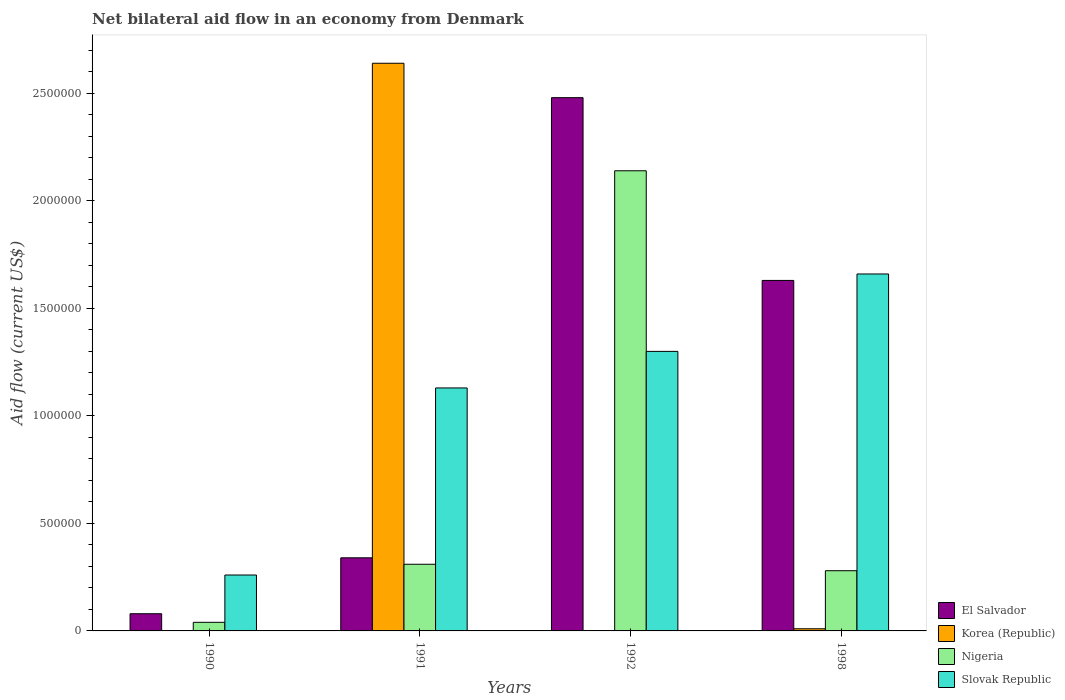In how many cases, is the number of bars for a given year not equal to the number of legend labels?
Your answer should be compact. 2. Across all years, what is the maximum net bilateral aid flow in Nigeria?
Offer a very short reply. 2.14e+06. Across all years, what is the minimum net bilateral aid flow in Korea (Republic)?
Provide a short and direct response. 0. In which year was the net bilateral aid flow in Nigeria maximum?
Make the answer very short. 1992. What is the total net bilateral aid flow in El Salvador in the graph?
Offer a very short reply. 4.53e+06. What is the difference between the net bilateral aid flow in Nigeria in 1992 and the net bilateral aid flow in El Salvador in 1998?
Your answer should be compact. 5.10e+05. What is the average net bilateral aid flow in Nigeria per year?
Ensure brevity in your answer.  6.92e+05. In the year 1998, what is the difference between the net bilateral aid flow in Slovak Republic and net bilateral aid flow in Nigeria?
Make the answer very short. 1.38e+06. In how many years, is the net bilateral aid flow in Slovak Republic greater than 2600000 US$?
Keep it short and to the point. 0. What is the ratio of the net bilateral aid flow in El Salvador in 1991 to that in 1992?
Your response must be concise. 0.14. Is the net bilateral aid flow in Slovak Republic in 1991 less than that in 1998?
Give a very brief answer. Yes. Is the difference between the net bilateral aid flow in Slovak Republic in 1991 and 1992 greater than the difference between the net bilateral aid flow in Nigeria in 1991 and 1992?
Make the answer very short. Yes. What is the difference between the highest and the second highest net bilateral aid flow in Nigeria?
Your answer should be compact. 1.83e+06. What is the difference between the highest and the lowest net bilateral aid flow in Slovak Republic?
Your answer should be very brief. 1.40e+06. In how many years, is the net bilateral aid flow in Korea (Republic) greater than the average net bilateral aid flow in Korea (Republic) taken over all years?
Your response must be concise. 1. How many bars are there?
Provide a succinct answer. 14. How many years are there in the graph?
Offer a terse response. 4. What is the difference between two consecutive major ticks on the Y-axis?
Offer a terse response. 5.00e+05. Are the values on the major ticks of Y-axis written in scientific E-notation?
Your answer should be very brief. No. Does the graph contain grids?
Ensure brevity in your answer.  No. How many legend labels are there?
Your response must be concise. 4. What is the title of the graph?
Provide a succinct answer. Net bilateral aid flow in an economy from Denmark. What is the label or title of the X-axis?
Provide a short and direct response. Years. What is the label or title of the Y-axis?
Make the answer very short. Aid flow (current US$). What is the Aid flow (current US$) of El Salvador in 1990?
Offer a terse response. 8.00e+04. What is the Aid flow (current US$) of Korea (Republic) in 1990?
Keep it short and to the point. 0. What is the Aid flow (current US$) of Slovak Republic in 1990?
Provide a succinct answer. 2.60e+05. What is the Aid flow (current US$) in Korea (Republic) in 1991?
Your answer should be compact. 2.64e+06. What is the Aid flow (current US$) in Slovak Republic in 1991?
Your answer should be very brief. 1.13e+06. What is the Aid flow (current US$) in El Salvador in 1992?
Offer a very short reply. 2.48e+06. What is the Aid flow (current US$) of Korea (Republic) in 1992?
Provide a succinct answer. 0. What is the Aid flow (current US$) of Nigeria in 1992?
Your answer should be very brief. 2.14e+06. What is the Aid flow (current US$) in Slovak Republic in 1992?
Your answer should be compact. 1.30e+06. What is the Aid flow (current US$) of El Salvador in 1998?
Your response must be concise. 1.63e+06. What is the Aid flow (current US$) in Korea (Republic) in 1998?
Provide a short and direct response. 10000. What is the Aid flow (current US$) of Nigeria in 1998?
Offer a terse response. 2.80e+05. What is the Aid flow (current US$) of Slovak Republic in 1998?
Provide a succinct answer. 1.66e+06. Across all years, what is the maximum Aid flow (current US$) of El Salvador?
Provide a short and direct response. 2.48e+06. Across all years, what is the maximum Aid flow (current US$) of Korea (Republic)?
Keep it short and to the point. 2.64e+06. Across all years, what is the maximum Aid flow (current US$) in Nigeria?
Make the answer very short. 2.14e+06. Across all years, what is the maximum Aid flow (current US$) of Slovak Republic?
Provide a short and direct response. 1.66e+06. Across all years, what is the minimum Aid flow (current US$) of Nigeria?
Keep it short and to the point. 4.00e+04. Across all years, what is the minimum Aid flow (current US$) in Slovak Republic?
Offer a terse response. 2.60e+05. What is the total Aid flow (current US$) in El Salvador in the graph?
Make the answer very short. 4.53e+06. What is the total Aid flow (current US$) of Korea (Republic) in the graph?
Make the answer very short. 2.65e+06. What is the total Aid flow (current US$) in Nigeria in the graph?
Offer a very short reply. 2.77e+06. What is the total Aid flow (current US$) in Slovak Republic in the graph?
Ensure brevity in your answer.  4.35e+06. What is the difference between the Aid flow (current US$) in Nigeria in 1990 and that in 1991?
Offer a terse response. -2.70e+05. What is the difference between the Aid flow (current US$) in Slovak Republic in 1990 and that in 1991?
Your response must be concise. -8.70e+05. What is the difference between the Aid flow (current US$) in El Salvador in 1990 and that in 1992?
Make the answer very short. -2.40e+06. What is the difference between the Aid flow (current US$) of Nigeria in 1990 and that in 1992?
Offer a terse response. -2.10e+06. What is the difference between the Aid flow (current US$) in Slovak Republic in 1990 and that in 1992?
Ensure brevity in your answer.  -1.04e+06. What is the difference between the Aid flow (current US$) in El Salvador in 1990 and that in 1998?
Provide a succinct answer. -1.55e+06. What is the difference between the Aid flow (current US$) of Slovak Republic in 1990 and that in 1998?
Ensure brevity in your answer.  -1.40e+06. What is the difference between the Aid flow (current US$) in El Salvador in 1991 and that in 1992?
Give a very brief answer. -2.14e+06. What is the difference between the Aid flow (current US$) in Nigeria in 1991 and that in 1992?
Offer a very short reply. -1.83e+06. What is the difference between the Aid flow (current US$) in El Salvador in 1991 and that in 1998?
Ensure brevity in your answer.  -1.29e+06. What is the difference between the Aid flow (current US$) of Korea (Republic) in 1991 and that in 1998?
Give a very brief answer. 2.63e+06. What is the difference between the Aid flow (current US$) in Slovak Republic in 1991 and that in 1998?
Your answer should be compact. -5.30e+05. What is the difference between the Aid flow (current US$) in El Salvador in 1992 and that in 1998?
Provide a succinct answer. 8.50e+05. What is the difference between the Aid flow (current US$) in Nigeria in 1992 and that in 1998?
Offer a terse response. 1.86e+06. What is the difference between the Aid flow (current US$) in Slovak Republic in 1992 and that in 1998?
Your response must be concise. -3.60e+05. What is the difference between the Aid flow (current US$) of El Salvador in 1990 and the Aid flow (current US$) of Korea (Republic) in 1991?
Offer a very short reply. -2.56e+06. What is the difference between the Aid flow (current US$) of El Salvador in 1990 and the Aid flow (current US$) of Slovak Republic in 1991?
Give a very brief answer. -1.05e+06. What is the difference between the Aid flow (current US$) in Nigeria in 1990 and the Aid flow (current US$) in Slovak Republic in 1991?
Your answer should be very brief. -1.09e+06. What is the difference between the Aid flow (current US$) of El Salvador in 1990 and the Aid flow (current US$) of Nigeria in 1992?
Ensure brevity in your answer.  -2.06e+06. What is the difference between the Aid flow (current US$) of El Salvador in 1990 and the Aid flow (current US$) of Slovak Republic in 1992?
Your answer should be compact. -1.22e+06. What is the difference between the Aid flow (current US$) in Nigeria in 1990 and the Aid flow (current US$) in Slovak Republic in 1992?
Provide a succinct answer. -1.26e+06. What is the difference between the Aid flow (current US$) in El Salvador in 1990 and the Aid flow (current US$) in Korea (Republic) in 1998?
Keep it short and to the point. 7.00e+04. What is the difference between the Aid flow (current US$) in El Salvador in 1990 and the Aid flow (current US$) in Nigeria in 1998?
Provide a short and direct response. -2.00e+05. What is the difference between the Aid flow (current US$) of El Salvador in 1990 and the Aid flow (current US$) of Slovak Republic in 1998?
Offer a terse response. -1.58e+06. What is the difference between the Aid flow (current US$) of Nigeria in 1990 and the Aid flow (current US$) of Slovak Republic in 1998?
Offer a very short reply. -1.62e+06. What is the difference between the Aid flow (current US$) of El Salvador in 1991 and the Aid flow (current US$) of Nigeria in 1992?
Keep it short and to the point. -1.80e+06. What is the difference between the Aid flow (current US$) of El Salvador in 1991 and the Aid flow (current US$) of Slovak Republic in 1992?
Your answer should be compact. -9.60e+05. What is the difference between the Aid flow (current US$) in Korea (Republic) in 1991 and the Aid flow (current US$) in Slovak Republic in 1992?
Provide a succinct answer. 1.34e+06. What is the difference between the Aid flow (current US$) of Nigeria in 1991 and the Aid flow (current US$) of Slovak Republic in 1992?
Your answer should be very brief. -9.90e+05. What is the difference between the Aid flow (current US$) of El Salvador in 1991 and the Aid flow (current US$) of Korea (Republic) in 1998?
Make the answer very short. 3.30e+05. What is the difference between the Aid flow (current US$) of El Salvador in 1991 and the Aid flow (current US$) of Slovak Republic in 1998?
Provide a short and direct response. -1.32e+06. What is the difference between the Aid flow (current US$) of Korea (Republic) in 1991 and the Aid flow (current US$) of Nigeria in 1998?
Keep it short and to the point. 2.36e+06. What is the difference between the Aid flow (current US$) in Korea (Republic) in 1991 and the Aid flow (current US$) in Slovak Republic in 1998?
Ensure brevity in your answer.  9.80e+05. What is the difference between the Aid flow (current US$) in Nigeria in 1991 and the Aid flow (current US$) in Slovak Republic in 1998?
Your answer should be compact. -1.35e+06. What is the difference between the Aid flow (current US$) of El Salvador in 1992 and the Aid flow (current US$) of Korea (Republic) in 1998?
Offer a terse response. 2.47e+06. What is the difference between the Aid flow (current US$) of El Salvador in 1992 and the Aid flow (current US$) of Nigeria in 1998?
Provide a short and direct response. 2.20e+06. What is the difference between the Aid flow (current US$) of El Salvador in 1992 and the Aid flow (current US$) of Slovak Republic in 1998?
Provide a short and direct response. 8.20e+05. What is the difference between the Aid flow (current US$) of Nigeria in 1992 and the Aid flow (current US$) of Slovak Republic in 1998?
Provide a short and direct response. 4.80e+05. What is the average Aid flow (current US$) in El Salvador per year?
Ensure brevity in your answer.  1.13e+06. What is the average Aid flow (current US$) in Korea (Republic) per year?
Make the answer very short. 6.62e+05. What is the average Aid flow (current US$) of Nigeria per year?
Provide a succinct answer. 6.92e+05. What is the average Aid flow (current US$) in Slovak Republic per year?
Your response must be concise. 1.09e+06. In the year 1990, what is the difference between the Aid flow (current US$) in El Salvador and Aid flow (current US$) in Nigeria?
Offer a very short reply. 4.00e+04. In the year 1990, what is the difference between the Aid flow (current US$) of El Salvador and Aid flow (current US$) of Slovak Republic?
Make the answer very short. -1.80e+05. In the year 1991, what is the difference between the Aid flow (current US$) of El Salvador and Aid flow (current US$) of Korea (Republic)?
Offer a terse response. -2.30e+06. In the year 1991, what is the difference between the Aid flow (current US$) in El Salvador and Aid flow (current US$) in Nigeria?
Keep it short and to the point. 3.00e+04. In the year 1991, what is the difference between the Aid flow (current US$) in El Salvador and Aid flow (current US$) in Slovak Republic?
Offer a very short reply. -7.90e+05. In the year 1991, what is the difference between the Aid flow (current US$) in Korea (Republic) and Aid flow (current US$) in Nigeria?
Make the answer very short. 2.33e+06. In the year 1991, what is the difference between the Aid flow (current US$) of Korea (Republic) and Aid flow (current US$) of Slovak Republic?
Your answer should be compact. 1.51e+06. In the year 1991, what is the difference between the Aid flow (current US$) of Nigeria and Aid flow (current US$) of Slovak Republic?
Give a very brief answer. -8.20e+05. In the year 1992, what is the difference between the Aid flow (current US$) in El Salvador and Aid flow (current US$) in Slovak Republic?
Your response must be concise. 1.18e+06. In the year 1992, what is the difference between the Aid flow (current US$) in Nigeria and Aid flow (current US$) in Slovak Republic?
Your response must be concise. 8.40e+05. In the year 1998, what is the difference between the Aid flow (current US$) in El Salvador and Aid flow (current US$) in Korea (Republic)?
Make the answer very short. 1.62e+06. In the year 1998, what is the difference between the Aid flow (current US$) in El Salvador and Aid flow (current US$) in Nigeria?
Give a very brief answer. 1.35e+06. In the year 1998, what is the difference between the Aid flow (current US$) of Korea (Republic) and Aid flow (current US$) of Slovak Republic?
Keep it short and to the point. -1.65e+06. In the year 1998, what is the difference between the Aid flow (current US$) in Nigeria and Aid flow (current US$) in Slovak Republic?
Give a very brief answer. -1.38e+06. What is the ratio of the Aid flow (current US$) of El Salvador in 1990 to that in 1991?
Make the answer very short. 0.24. What is the ratio of the Aid flow (current US$) of Nigeria in 1990 to that in 1991?
Your answer should be compact. 0.13. What is the ratio of the Aid flow (current US$) in Slovak Republic in 1990 to that in 1991?
Your answer should be very brief. 0.23. What is the ratio of the Aid flow (current US$) of El Salvador in 1990 to that in 1992?
Provide a short and direct response. 0.03. What is the ratio of the Aid flow (current US$) in Nigeria in 1990 to that in 1992?
Your answer should be very brief. 0.02. What is the ratio of the Aid flow (current US$) of Slovak Republic in 1990 to that in 1992?
Keep it short and to the point. 0.2. What is the ratio of the Aid flow (current US$) in El Salvador in 1990 to that in 1998?
Provide a succinct answer. 0.05. What is the ratio of the Aid flow (current US$) of Nigeria in 1990 to that in 1998?
Your answer should be compact. 0.14. What is the ratio of the Aid flow (current US$) in Slovak Republic in 1990 to that in 1998?
Your response must be concise. 0.16. What is the ratio of the Aid flow (current US$) in El Salvador in 1991 to that in 1992?
Provide a succinct answer. 0.14. What is the ratio of the Aid flow (current US$) of Nigeria in 1991 to that in 1992?
Keep it short and to the point. 0.14. What is the ratio of the Aid flow (current US$) of Slovak Republic in 1991 to that in 1992?
Your response must be concise. 0.87. What is the ratio of the Aid flow (current US$) of El Salvador in 1991 to that in 1998?
Offer a very short reply. 0.21. What is the ratio of the Aid flow (current US$) of Korea (Republic) in 1991 to that in 1998?
Offer a very short reply. 264. What is the ratio of the Aid flow (current US$) of Nigeria in 1991 to that in 1998?
Provide a succinct answer. 1.11. What is the ratio of the Aid flow (current US$) of Slovak Republic in 1991 to that in 1998?
Keep it short and to the point. 0.68. What is the ratio of the Aid flow (current US$) in El Salvador in 1992 to that in 1998?
Your answer should be very brief. 1.52. What is the ratio of the Aid flow (current US$) of Nigeria in 1992 to that in 1998?
Keep it short and to the point. 7.64. What is the ratio of the Aid flow (current US$) of Slovak Republic in 1992 to that in 1998?
Your answer should be very brief. 0.78. What is the difference between the highest and the second highest Aid flow (current US$) of El Salvador?
Provide a succinct answer. 8.50e+05. What is the difference between the highest and the second highest Aid flow (current US$) of Nigeria?
Offer a terse response. 1.83e+06. What is the difference between the highest and the lowest Aid flow (current US$) in El Salvador?
Your response must be concise. 2.40e+06. What is the difference between the highest and the lowest Aid flow (current US$) of Korea (Republic)?
Provide a succinct answer. 2.64e+06. What is the difference between the highest and the lowest Aid flow (current US$) of Nigeria?
Your answer should be compact. 2.10e+06. What is the difference between the highest and the lowest Aid flow (current US$) in Slovak Republic?
Ensure brevity in your answer.  1.40e+06. 